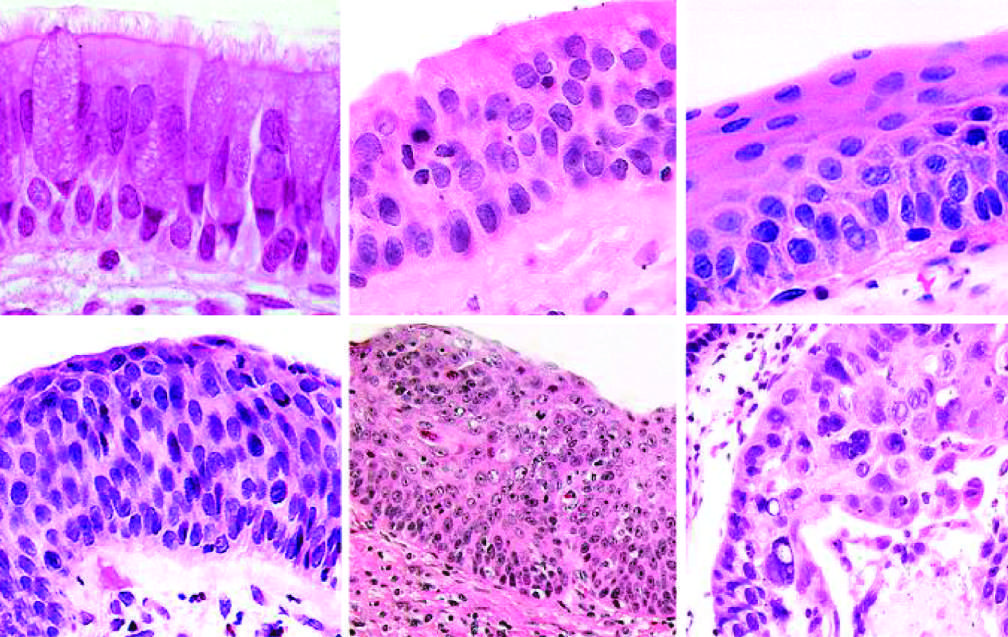s stillbirth the stage that immediately precedes invasive squamous cell carcinoma?
Answer the question using a single word or phrase. No 